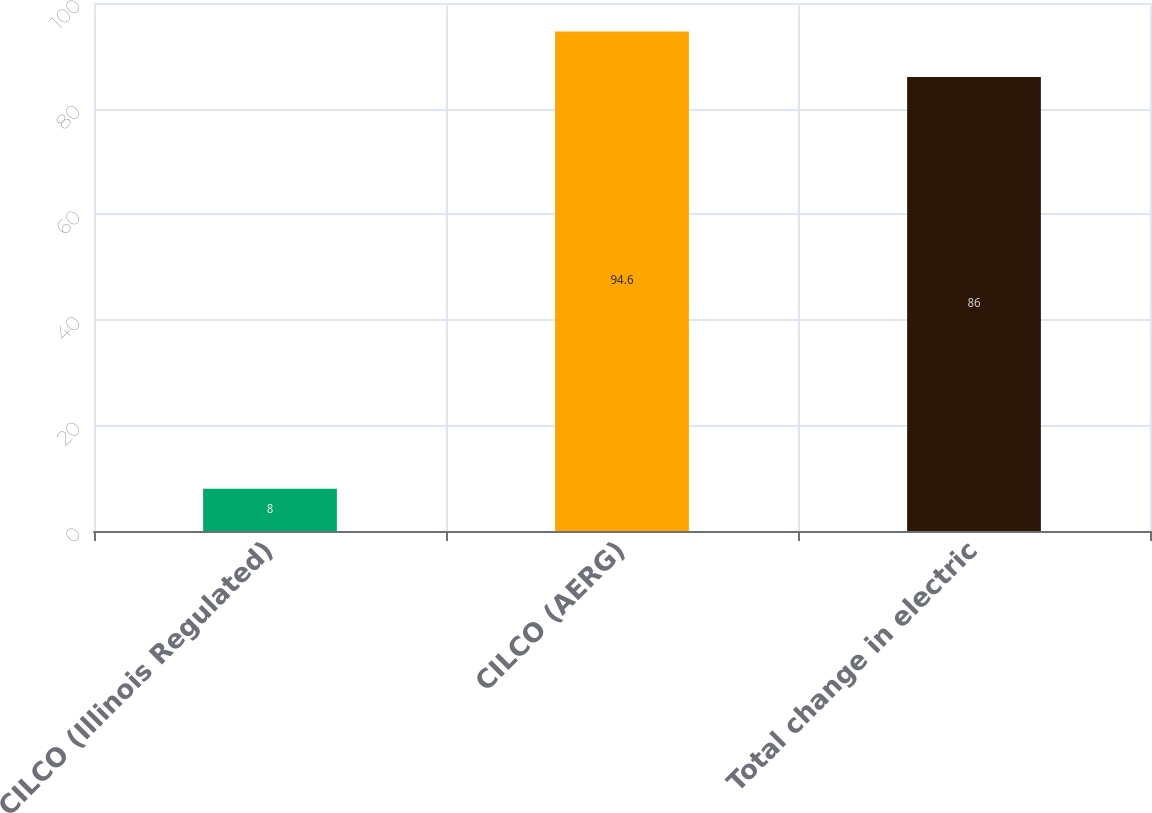Convert chart to OTSL. <chart><loc_0><loc_0><loc_500><loc_500><bar_chart><fcel>CILCO (Illinois Regulated)<fcel>CILCO (AERG)<fcel>Total change in electric<nl><fcel>8<fcel>94.6<fcel>86<nl></chart> 